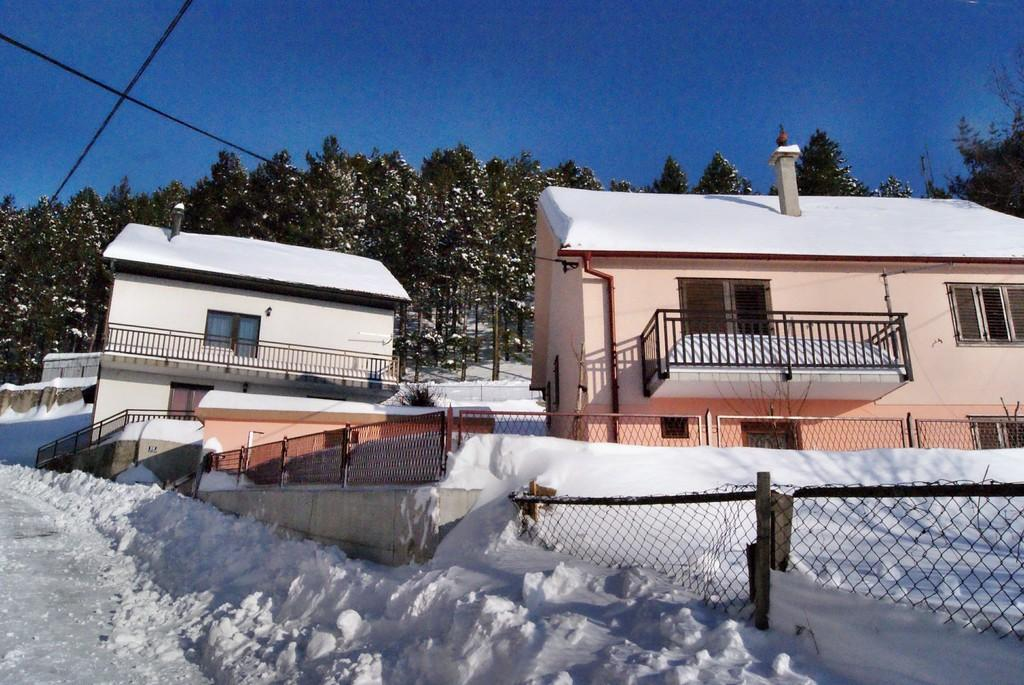What type of weather is depicted in the image? There is snow in the image, indicating a winter scene. What is located at the bottom of the image? There is a fence at the bottom of the image. What can be seen in the background of the image? There are buildings and trees in the background of the image. What is visible at the top of the image? The sky is visible at the top of the image. What type of art can be seen on the fence in the image? There is no art present on the fence in the image; it is a plain fence. Can you tell me the position of the worm in the image? There is no worm present in the image. 